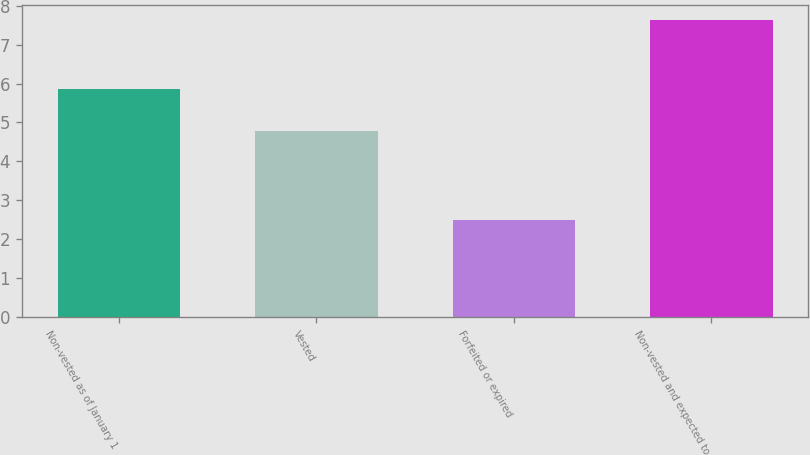Convert chart. <chart><loc_0><loc_0><loc_500><loc_500><bar_chart><fcel>Non-vested as of January 1<fcel>Vested<fcel>Forfeited or expired<fcel>Non-vested and expected to<nl><fcel>5.87<fcel>4.79<fcel>2.5<fcel>7.63<nl></chart> 